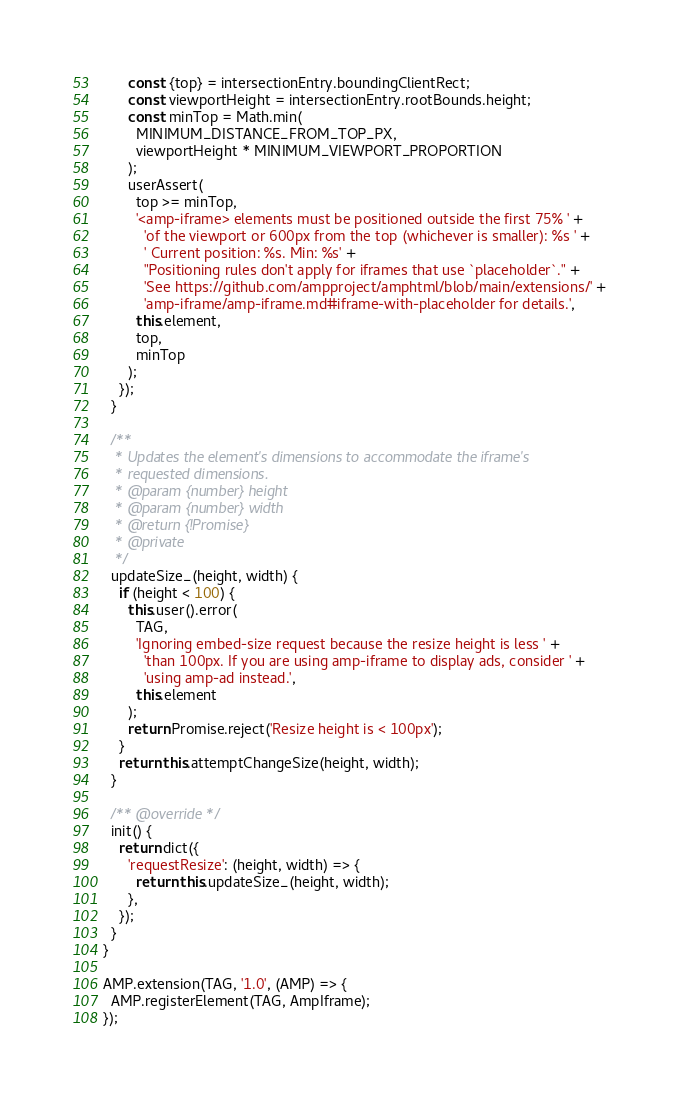Convert code to text. <code><loc_0><loc_0><loc_500><loc_500><_JavaScript_>      const {top} = intersectionEntry.boundingClientRect;
      const viewportHeight = intersectionEntry.rootBounds.height;
      const minTop = Math.min(
        MINIMUM_DISTANCE_FROM_TOP_PX,
        viewportHeight * MINIMUM_VIEWPORT_PROPORTION
      );
      userAssert(
        top >= minTop,
        '<amp-iframe> elements must be positioned outside the first 75% ' +
          'of the viewport or 600px from the top (whichever is smaller): %s ' +
          ' Current position: %s. Min: %s' +
          "Positioning rules don't apply for iframes that use `placeholder`." +
          'See https://github.com/ampproject/amphtml/blob/main/extensions/' +
          'amp-iframe/amp-iframe.md#iframe-with-placeholder for details.',
        this.element,
        top,
        minTop
      );
    });
  }

  /**
   * Updates the element's dimensions to accommodate the iframe's
   * requested dimensions.
   * @param {number} height
   * @param {number} width
   * @return {!Promise}
   * @private
   */
  updateSize_(height, width) {
    if (height < 100) {
      this.user().error(
        TAG,
        'Ignoring embed-size request because the resize height is less ' +
          'than 100px. If you are using amp-iframe to display ads, consider ' +
          'using amp-ad instead.',
        this.element
      );
      return Promise.reject('Resize height is < 100px');
    }
    return this.attemptChangeSize(height, width);
  }

  /** @override */
  init() {
    return dict({
      'requestResize': (height, width) => {
        return this.updateSize_(height, width);
      },
    });
  }
}

AMP.extension(TAG, '1.0', (AMP) => {
  AMP.registerElement(TAG, AmpIframe);
});
</code> 